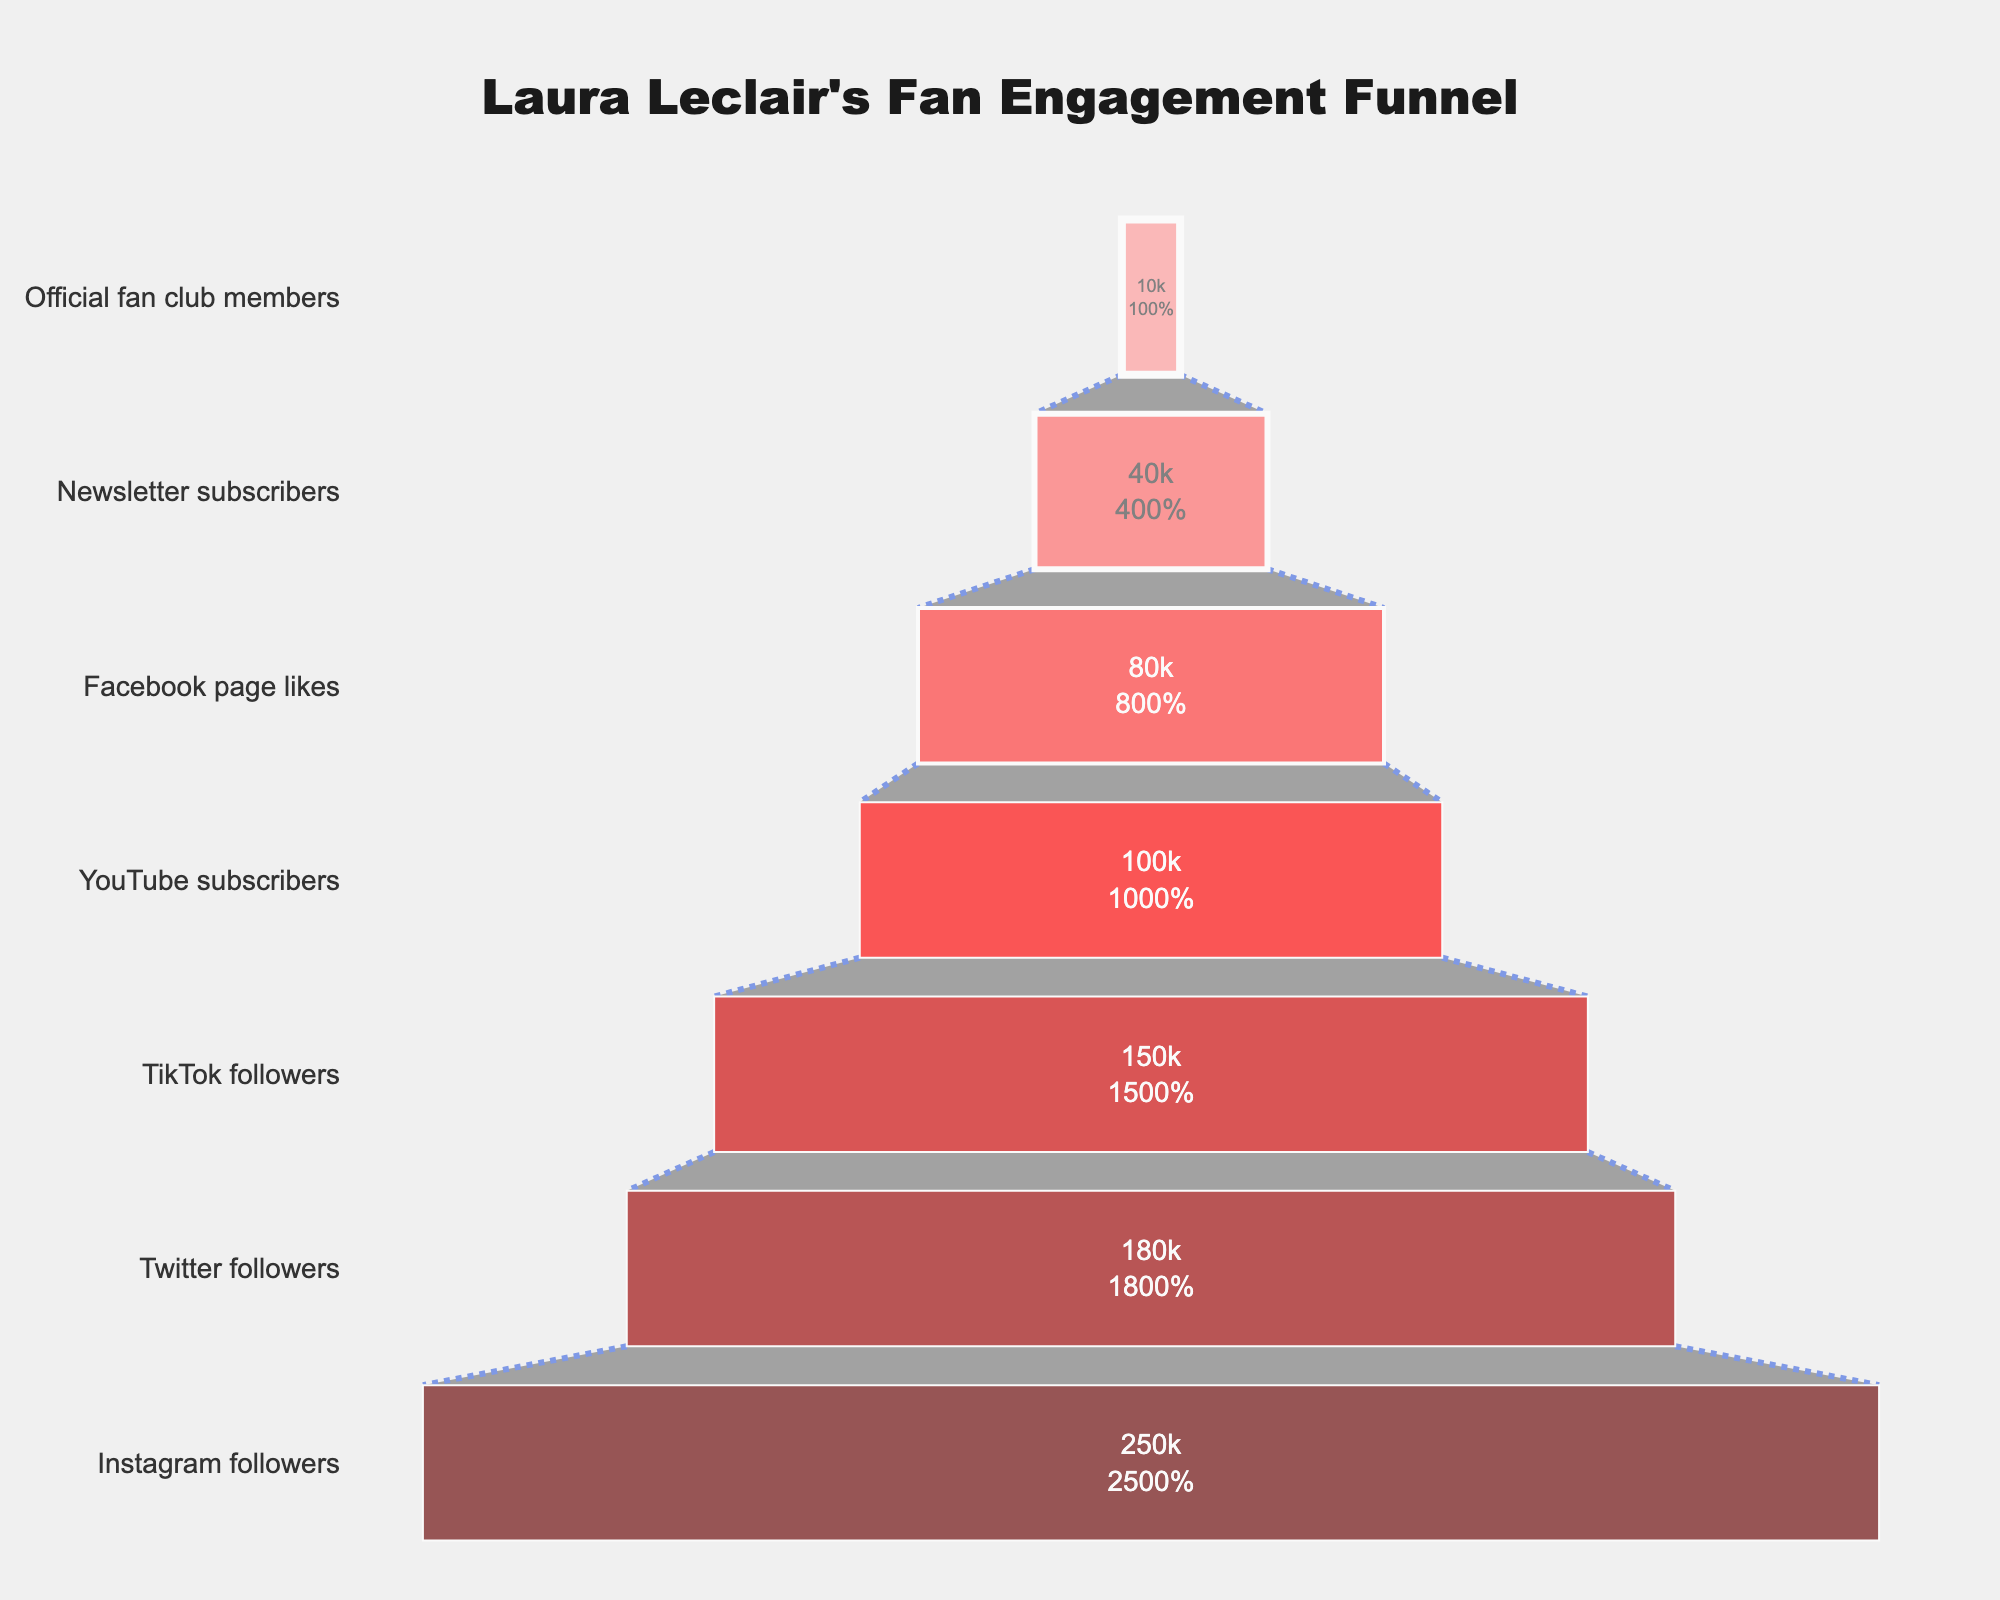What is the title of the funnel chart? The title of the funnel chart is displayed at the top of the figure. It reads "Laura Leclair's Fan Engagement Funnel".
Answer: Laura Leclair's Fan Engagement Funnel How many total social media platforms and categories are displayed in the funnel chart? Count each category listed in the Y-axis of the chart. There are seven categories displayed: Instagram followers, Twitter followers, TikTok followers, YouTube subscribers, Facebook page likes, Newsletter subscribers, and Official fan club members.
Answer: 7 Which stage has the highest number of followers? Look at the values listed inside the chart. The stage with the highest number of followers is "Instagram followers" with 250,000 followers.
Answer: Instagram followers How many more Instagram followers are there compared to Facebook page likes? Subtract the number of Facebook page likes from the number of Instagram followers: 250,000 - 80,000 = 170,000.
Answer: 170,000 What percentage of initial followers are Instagram followers? This information is displayed inside the chart under "Instagram followers". Instagram followers are 100% of the initial followers.
Answer: 100% What is the difference between TikTok followers and YouTube subscribers? Subtract the number of YouTube subscribers from the number of TikTok followers: 150,000 - 100,000 = 50,000.
Answer: 50,000 Which category has the lowest engagement? Look at the values listed inside the chart. The lowest number is under "Official fan club members" with 10,000 members.
Answer: Official fan club members What percentage drop is there from TikTok followers to YouTube subscribers? First, find the number of followers lost: 150,000 (TikTok) - 100,000 (YouTube). Then, divide this by the initial TikTok followers and multiply by 100 to get the percentage: (50,000 / 150,000) * 100 = 33.33%.
Answer: 33.33% What is the total number of followers across all stages? Sum the number of followers in each stage: 250,000 (Instagram) + 180,000 (Twitter) + 150,000 (TikTok) + 100,000 (YouTube) + 80,000 (Facebook) + 40,000 (Newsletter) + 10,000 (Official fan club) = 810,000.
Answer: 810,000 